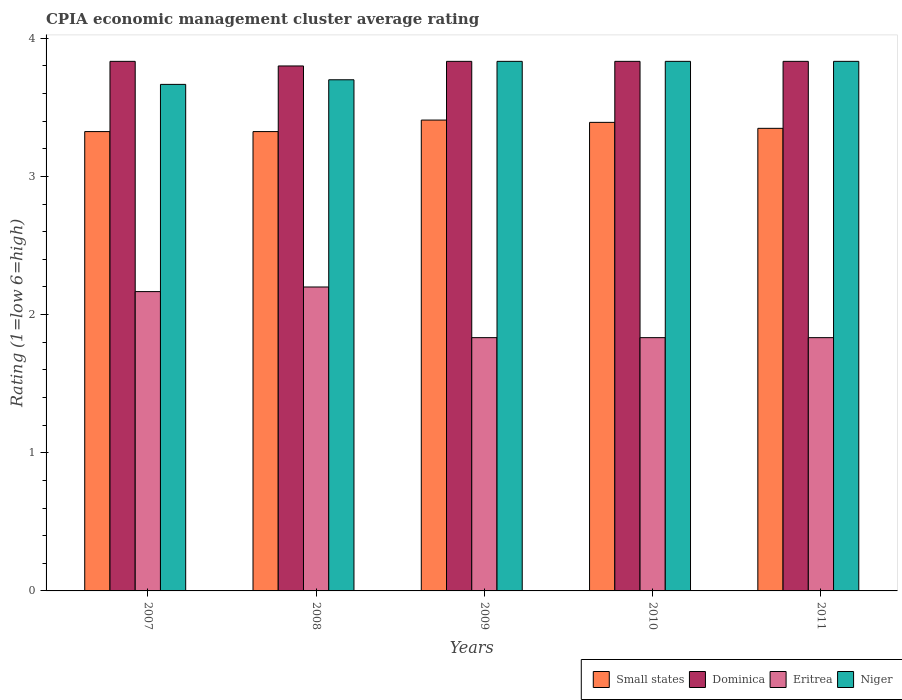How many different coloured bars are there?
Keep it short and to the point. 4. How many bars are there on the 2nd tick from the right?
Keep it short and to the point. 4. What is the CPIA rating in Dominica in 2009?
Make the answer very short. 3.83. Across all years, what is the maximum CPIA rating in Eritrea?
Your answer should be very brief. 2.2. Across all years, what is the minimum CPIA rating in Eritrea?
Your answer should be very brief. 1.83. In which year was the CPIA rating in Eritrea maximum?
Offer a very short reply. 2008. What is the total CPIA rating in Dominica in the graph?
Your answer should be very brief. 19.13. What is the difference between the CPIA rating in Small states in 2009 and that in 2010?
Your answer should be compact. 0.02. What is the difference between the CPIA rating in Eritrea in 2008 and the CPIA rating in Small states in 2010?
Ensure brevity in your answer.  -1.19. What is the average CPIA rating in Dominica per year?
Give a very brief answer. 3.83. In the year 2009, what is the difference between the CPIA rating in Eritrea and CPIA rating in Small states?
Your response must be concise. -1.58. In how many years, is the CPIA rating in Eritrea greater than 3.2?
Make the answer very short. 0. What is the ratio of the CPIA rating in Eritrea in 2009 to that in 2011?
Give a very brief answer. 1. What is the difference between the highest and the second highest CPIA rating in Small states?
Offer a very short reply. 0.02. What is the difference between the highest and the lowest CPIA rating in Eritrea?
Make the answer very short. 0.37. What does the 3rd bar from the left in 2009 represents?
Your response must be concise. Eritrea. What does the 3rd bar from the right in 2011 represents?
Provide a succinct answer. Dominica. Is it the case that in every year, the sum of the CPIA rating in Dominica and CPIA rating in Eritrea is greater than the CPIA rating in Niger?
Ensure brevity in your answer.  Yes. How many bars are there?
Your response must be concise. 20. Are the values on the major ticks of Y-axis written in scientific E-notation?
Ensure brevity in your answer.  No. Does the graph contain grids?
Offer a terse response. No. Where does the legend appear in the graph?
Keep it short and to the point. Bottom right. How many legend labels are there?
Provide a succinct answer. 4. What is the title of the graph?
Give a very brief answer. CPIA economic management cluster average rating. What is the label or title of the Y-axis?
Your response must be concise. Rating (1=low 6=high). What is the Rating (1=low 6=high) in Small states in 2007?
Give a very brief answer. 3.33. What is the Rating (1=low 6=high) of Dominica in 2007?
Offer a very short reply. 3.83. What is the Rating (1=low 6=high) of Eritrea in 2007?
Give a very brief answer. 2.17. What is the Rating (1=low 6=high) of Niger in 2007?
Your answer should be compact. 3.67. What is the Rating (1=low 6=high) in Small states in 2008?
Provide a short and direct response. 3.33. What is the Rating (1=low 6=high) in Dominica in 2008?
Give a very brief answer. 3.8. What is the Rating (1=low 6=high) in Eritrea in 2008?
Give a very brief answer. 2.2. What is the Rating (1=low 6=high) of Niger in 2008?
Ensure brevity in your answer.  3.7. What is the Rating (1=low 6=high) in Small states in 2009?
Your answer should be compact. 3.41. What is the Rating (1=low 6=high) in Dominica in 2009?
Provide a succinct answer. 3.83. What is the Rating (1=low 6=high) in Eritrea in 2009?
Provide a short and direct response. 1.83. What is the Rating (1=low 6=high) in Niger in 2009?
Provide a short and direct response. 3.83. What is the Rating (1=low 6=high) in Small states in 2010?
Provide a succinct answer. 3.39. What is the Rating (1=low 6=high) in Dominica in 2010?
Keep it short and to the point. 3.83. What is the Rating (1=low 6=high) in Eritrea in 2010?
Keep it short and to the point. 1.83. What is the Rating (1=low 6=high) in Niger in 2010?
Provide a succinct answer. 3.83. What is the Rating (1=low 6=high) in Small states in 2011?
Offer a terse response. 3.35. What is the Rating (1=low 6=high) in Dominica in 2011?
Ensure brevity in your answer.  3.83. What is the Rating (1=low 6=high) in Eritrea in 2011?
Your answer should be very brief. 1.83. What is the Rating (1=low 6=high) of Niger in 2011?
Your answer should be very brief. 3.83. Across all years, what is the maximum Rating (1=low 6=high) in Small states?
Your answer should be very brief. 3.41. Across all years, what is the maximum Rating (1=low 6=high) in Dominica?
Keep it short and to the point. 3.83. Across all years, what is the maximum Rating (1=low 6=high) of Eritrea?
Keep it short and to the point. 2.2. Across all years, what is the maximum Rating (1=low 6=high) in Niger?
Keep it short and to the point. 3.83. Across all years, what is the minimum Rating (1=low 6=high) in Small states?
Your answer should be very brief. 3.33. Across all years, what is the minimum Rating (1=low 6=high) of Dominica?
Your response must be concise. 3.8. Across all years, what is the minimum Rating (1=low 6=high) in Eritrea?
Provide a succinct answer. 1.83. Across all years, what is the minimum Rating (1=low 6=high) in Niger?
Keep it short and to the point. 3.67. What is the total Rating (1=low 6=high) in Small states in the graph?
Make the answer very short. 16.8. What is the total Rating (1=low 6=high) of Dominica in the graph?
Give a very brief answer. 19.13. What is the total Rating (1=low 6=high) of Eritrea in the graph?
Ensure brevity in your answer.  9.87. What is the total Rating (1=low 6=high) in Niger in the graph?
Ensure brevity in your answer.  18.87. What is the difference between the Rating (1=low 6=high) of Dominica in 2007 and that in 2008?
Provide a succinct answer. 0.03. What is the difference between the Rating (1=low 6=high) of Eritrea in 2007 and that in 2008?
Provide a succinct answer. -0.03. What is the difference between the Rating (1=low 6=high) of Niger in 2007 and that in 2008?
Your answer should be very brief. -0.03. What is the difference between the Rating (1=low 6=high) in Small states in 2007 and that in 2009?
Your response must be concise. -0.08. What is the difference between the Rating (1=low 6=high) in Dominica in 2007 and that in 2009?
Ensure brevity in your answer.  0. What is the difference between the Rating (1=low 6=high) of Small states in 2007 and that in 2010?
Offer a terse response. -0.07. What is the difference between the Rating (1=low 6=high) in Dominica in 2007 and that in 2010?
Your answer should be compact. 0. What is the difference between the Rating (1=low 6=high) of Small states in 2007 and that in 2011?
Ensure brevity in your answer.  -0.02. What is the difference between the Rating (1=low 6=high) of Eritrea in 2007 and that in 2011?
Your answer should be compact. 0.33. What is the difference between the Rating (1=low 6=high) of Niger in 2007 and that in 2011?
Keep it short and to the point. -0.17. What is the difference between the Rating (1=low 6=high) in Small states in 2008 and that in 2009?
Offer a very short reply. -0.08. What is the difference between the Rating (1=low 6=high) in Dominica in 2008 and that in 2009?
Provide a short and direct response. -0.03. What is the difference between the Rating (1=low 6=high) of Eritrea in 2008 and that in 2009?
Your response must be concise. 0.37. What is the difference between the Rating (1=low 6=high) in Niger in 2008 and that in 2009?
Give a very brief answer. -0.13. What is the difference between the Rating (1=low 6=high) in Small states in 2008 and that in 2010?
Offer a very short reply. -0.07. What is the difference between the Rating (1=low 6=high) in Dominica in 2008 and that in 2010?
Your answer should be compact. -0.03. What is the difference between the Rating (1=low 6=high) in Eritrea in 2008 and that in 2010?
Provide a succinct answer. 0.37. What is the difference between the Rating (1=low 6=high) of Niger in 2008 and that in 2010?
Your answer should be compact. -0.13. What is the difference between the Rating (1=low 6=high) of Small states in 2008 and that in 2011?
Your answer should be compact. -0.02. What is the difference between the Rating (1=low 6=high) of Dominica in 2008 and that in 2011?
Make the answer very short. -0.03. What is the difference between the Rating (1=low 6=high) in Eritrea in 2008 and that in 2011?
Give a very brief answer. 0.37. What is the difference between the Rating (1=low 6=high) in Niger in 2008 and that in 2011?
Your answer should be very brief. -0.13. What is the difference between the Rating (1=low 6=high) in Small states in 2009 and that in 2010?
Your answer should be compact. 0.02. What is the difference between the Rating (1=low 6=high) of Dominica in 2009 and that in 2010?
Provide a short and direct response. 0. What is the difference between the Rating (1=low 6=high) in Eritrea in 2009 and that in 2010?
Your response must be concise. 0. What is the difference between the Rating (1=low 6=high) of Niger in 2009 and that in 2010?
Your answer should be very brief. 0. What is the difference between the Rating (1=low 6=high) of Small states in 2009 and that in 2011?
Your response must be concise. 0.06. What is the difference between the Rating (1=low 6=high) in Dominica in 2009 and that in 2011?
Provide a succinct answer. 0. What is the difference between the Rating (1=low 6=high) in Eritrea in 2009 and that in 2011?
Your answer should be compact. 0. What is the difference between the Rating (1=low 6=high) of Small states in 2010 and that in 2011?
Provide a short and direct response. 0.04. What is the difference between the Rating (1=low 6=high) in Small states in 2007 and the Rating (1=low 6=high) in Dominica in 2008?
Your answer should be compact. -0.47. What is the difference between the Rating (1=low 6=high) of Small states in 2007 and the Rating (1=low 6=high) of Niger in 2008?
Provide a succinct answer. -0.38. What is the difference between the Rating (1=low 6=high) of Dominica in 2007 and the Rating (1=low 6=high) of Eritrea in 2008?
Offer a terse response. 1.63. What is the difference between the Rating (1=low 6=high) of Dominica in 2007 and the Rating (1=low 6=high) of Niger in 2008?
Your response must be concise. 0.13. What is the difference between the Rating (1=low 6=high) of Eritrea in 2007 and the Rating (1=low 6=high) of Niger in 2008?
Your answer should be very brief. -1.53. What is the difference between the Rating (1=low 6=high) of Small states in 2007 and the Rating (1=low 6=high) of Dominica in 2009?
Ensure brevity in your answer.  -0.51. What is the difference between the Rating (1=low 6=high) of Small states in 2007 and the Rating (1=low 6=high) of Eritrea in 2009?
Provide a succinct answer. 1.49. What is the difference between the Rating (1=low 6=high) of Small states in 2007 and the Rating (1=low 6=high) of Niger in 2009?
Your answer should be compact. -0.51. What is the difference between the Rating (1=low 6=high) of Dominica in 2007 and the Rating (1=low 6=high) of Niger in 2009?
Offer a terse response. 0. What is the difference between the Rating (1=low 6=high) of Eritrea in 2007 and the Rating (1=low 6=high) of Niger in 2009?
Ensure brevity in your answer.  -1.67. What is the difference between the Rating (1=low 6=high) of Small states in 2007 and the Rating (1=low 6=high) of Dominica in 2010?
Offer a terse response. -0.51. What is the difference between the Rating (1=low 6=high) of Small states in 2007 and the Rating (1=low 6=high) of Eritrea in 2010?
Provide a short and direct response. 1.49. What is the difference between the Rating (1=low 6=high) in Small states in 2007 and the Rating (1=low 6=high) in Niger in 2010?
Offer a very short reply. -0.51. What is the difference between the Rating (1=low 6=high) in Dominica in 2007 and the Rating (1=low 6=high) in Niger in 2010?
Ensure brevity in your answer.  0. What is the difference between the Rating (1=low 6=high) in Eritrea in 2007 and the Rating (1=low 6=high) in Niger in 2010?
Your response must be concise. -1.67. What is the difference between the Rating (1=low 6=high) of Small states in 2007 and the Rating (1=low 6=high) of Dominica in 2011?
Your answer should be very brief. -0.51. What is the difference between the Rating (1=low 6=high) in Small states in 2007 and the Rating (1=low 6=high) in Eritrea in 2011?
Keep it short and to the point. 1.49. What is the difference between the Rating (1=low 6=high) of Small states in 2007 and the Rating (1=low 6=high) of Niger in 2011?
Make the answer very short. -0.51. What is the difference between the Rating (1=low 6=high) of Eritrea in 2007 and the Rating (1=low 6=high) of Niger in 2011?
Offer a very short reply. -1.67. What is the difference between the Rating (1=low 6=high) of Small states in 2008 and the Rating (1=low 6=high) of Dominica in 2009?
Give a very brief answer. -0.51. What is the difference between the Rating (1=low 6=high) in Small states in 2008 and the Rating (1=low 6=high) in Eritrea in 2009?
Provide a short and direct response. 1.49. What is the difference between the Rating (1=low 6=high) of Small states in 2008 and the Rating (1=low 6=high) of Niger in 2009?
Make the answer very short. -0.51. What is the difference between the Rating (1=low 6=high) of Dominica in 2008 and the Rating (1=low 6=high) of Eritrea in 2009?
Ensure brevity in your answer.  1.97. What is the difference between the Rating (1=low 6=high) in Dominica in 2008 and the Rating (1=low 6=high) in Niger in 2009?
Your response must be concise. -0.03. What is the difference between the Rating (1=low 6=high) of Eritrea in 2008 and the Rating (1=low 6=high) of Niger in 2009?
Offer a terse response. -1.63. What is the difference between the Rating (1=low 6=high) of Small states in 2008 and the Rating (1=low 6=high) of Dominica in 2010?
Offer a very short reply. -0.51. What is the difference between the Rating (1=low 6=high) in Small states in 2008 and the Rating (1=low 6=high) in Eritrea in 2010?
Provide a succinct answer. 1.49. What is the difference between the Rating (1=low 6=high) of Small states in 2008 and the Rating (1=low 6=high) of Niger in 2010?
Your answer should be very brief. -0.51. What is the difference between the Rating (1=low 6=high) in Dominica in 2008 and the Rating (1=low 6=high) in Eritrea in 2010?
Ensure brevity in your answer.  1.97. What is the difference between the Rating (1=low 6=high) of Dominica in 2008 and the Rating (1=low 6=high) of Niger in 2010?
Your answer should be compact. -0.03. What is the difference between the Rating (1=low 6=high) of Eritrea in 2008 and the Rating (1=low 6=high) of Niger in 2010?
Your response must be concise. -1.63. What is the difference between the Rating (1=low 6=high) in Small states in 2008 and the Rating (1=low 6=high) in Dominica in 2011?
Provide a succinct answer. -0.51. What is the difference between the Rating (1=low 6=high) of Small states in 2008 and the Rating (1=low 6=high) of Eritrea in 2011?
Your response must be concise. 1.49. What is the difference between the Rating (1=low 6=high) in Small states in 2008 and the Rating (1=low 6=high) in Niger in 2011?
Provide a short and direct response. -0.51. What is the difference between the Rating (1=low 6=high) of Dominica in 2008 and the Rating (1=low 6=high) of Eritrea in 2011?
Provide a succinct answer. 1.97. What is the difference between the Rating (1=low 6=high) of Dominica in 2008 and the Rating (1=low 6=high) of Niger in 2011?
Your answer should be compact. -0.03. What is the difference between the Rating (1=low 6=high) of Eritrea in 2008 and the Rating (1=low 6=high) of Niger in 2011?
Keep it short and to the point. -1.63. What is the difference between the Rating (1=low 6=high) of Small states in 2009 and the Rating (1=low 6=high) of Dominica in 2010?
Provide a succinct answer. -0.42. What is the difference between the Rating (1=low 6=high) in Small states in 2009 and the Rating (1=low 6=high) in Eritrea in 2010?
Give a very brief answer. 1.57. What is the difference between the Rating (1=low 6=high) of Small states in 2009 and the Rating (1=low 6=high) of Niger in 2010?
Your answer should be very brief. -0.42. What is the difference between the Rating (1=low 6=high) of Dominica in 2009 and the Rating (1=low 6=high) of Eritrea in 2010?
Make the answer very short. 2. What is the difference between the Rating (1=low 6=high) in Eritrea in 2009 and the Rating (1=low 6=high) in Niger in 2010?
Keep it short and to the point. -2. What is the difference between the Rating (1=low 6=high) of Small states in 2009 and the Rating (1=low 6=high) of Dominica in 2011?
Keep it short and to the point. -0.42. What is the difference between the Rating (1=low 6=high) of Small states in 2009 and the Rating (1=low 6=high) of Eritrea in 2011?
Provide a short and direct response. 1.57. What is the difference between the Rating (1=low 6=high) of Small states in 2009 and the Rating (1=low 6=high) of Niger in 2011?
Make the answer very short. -0.42. What is the difference between the Rating (1=low 6=high) in Dominica in 2009 and the Rating (1=low 6=high) in Eritrea in 2011?
Keep it short and to the point. 2. What is the difference between the Rating (1=low 6=high) of Small states in 2010 and the Rating (1=low 6=high) of Dominica in 2011?
Offer a very short reply. -0.44. What is the difference between the Rating (1=low 6=high) in Small states in 2010 and the Rating (1=low 6=high) in Eritrea in 2011?
Provide a short and direct response. 1.56. What is the difference between the Rating (1=low 6=high) of Small states in 2010 and the Rating (1=low 6=high) of Niger in 2011?
Keep it short and to the point. -0.44. What is the difference between the Rating (1=low 6=high) in Dominica in 2010 and the Rating (1=low 6=high) in Eritrea in 2011?
Your response must be concise. 2. What is the average Rating (1=low 6=high) of Small states per year?
Ensure brevity in your answer.  3.36. What is the average Rating (1=low 6=high) in Dominica per year?
Provide a short and direct response. 3.83. What is the average Rating (1=low 6=high) in Eritrea per year?
Give a very brief answer. 1.97. What is the average Rating (1=low 6=high) of Niger per year?
Offer a very short reply. 3.77. In the year 2007, what is the difference between the Rating (1=low 6=high) of Small states and Rating (1=low 6=high) of Dominica?
Offer a terse response. -0.51. In the year 2007, what is the difference between the Rating (1=low 6=high) of Small states and Rating (1=low 6=high) of Eritrea?
Make the answer very short. 1.16. In the year 2007, what is the difference between the Rating (1=low 6=high) of Small states and Rating (1=low 6=high) of Niger?
Make the answer very short. -0.34. In the year 2007, what is the difference between the Rating (1=low 6=high) in Dominica and Rating (1=low 6=high) in Eritrea?
Offer a very short reply. 1.67. In the year 2007, what is the difference between the Rating (1=low 6=high) of Eritrea and Rating (1=low 6=high) of Niger?
Your answer should be very brief. -1.5. In the year 2008, what is the difference between the Rating (1=low 6=high) of Small states and Rating (1=low 6=high) of Dominica?
Ensure brevity in your answer.  -0.47. In the year 2008, what is the difference between the Rating (1=low 6=high) of Small states and Rating (1=low 6=high) of Niger?
Provide a short and direct response. -0.38. In the year 2008, what is the difference between the Rating (1=low 6=high) of Dominica and Rating (1=low 6=high) of Niger?
Offer a very short reply. 0.1. In the year 2009, what is the difference between the Rating (1=low 6=high) of Small states and Rating (1=low 6=high) of Dominica?
Keep it short and to the point. -0.42. In the year 2009, what is the difference between the Rating (1=low 6=high) of Small states and Rating (1=low 6=high) of Eritrea?
Keep it short and to the point. 1.57. In the year 2009, what is the difference between the Rating (1=low 6=high) of Small states and Rating (1=low 6=high) of Niger?
Your response must be concise. -0.42. In the year 2009, what is the difference between the Rating (1=low 6=high) in Dominica and Rating (1=low 6=high) in Niger?
Offer a very short reply. 0. In the year 2010, what is the difference between the Rating (1=low 6=high) of Small states and Rating (1=low 6=high) of Dominica?
Keep it short and to the point. -0.44. In the year 2010, what is the difference between the Rating (1=low 6=high) in Small states and Rating (1=low 6=high) in Eritrea?
Provide a succinct answer. 1.56. In the year 2010, what is the difference between the Rating (1=low 6=high) of Small states and Rating (1=low 6=high) of Niger?
Make the answer very short. -0.44. In the year 2011, what is the difference between the Rating (1=low 6=high) of Small states and Rating (1=low 6=high) of Dominica?
Your answer should be very brief. -0.48. In the year 2011, what is the difference between the Rating (1=low 6=high) of Small states and Rating (1=low 6=high) of Eritrea?
Provide a short and direct response. 1.52. In the year 2011, what is the difference between the Rating (1=low 6=high) of Small states and Rating (1=low 6=high) of Niger?
Provide a short and direct response. -0.48. In the year 2011, what is the difference between the Rating (1=low 6=high) in Dominica and Rating (1=low 6=high) in Eritrea?
Your answer should be compact. 2. In the year 2011, what is the difference between the Rating (1=low 6=high) of Dominica and Rating (1=low 6=high) of Niger?
Offer a very short reply. 0. What is the ratio of the Rating (1=low 6=high) of Dominica in 2007 to that in 2008?
Ensure brevity in your answer.  1.01. What is the ratio of the Rating (1=low 6=high) of Eritrea in 2007 to that in 2008?
Your answer should be compact. 0.98. What is the ratio of the Rating (1=low 6=high) of Small states in 2007 to that in 2009?
Make the answer very short. 0.98. What is the ratio of the Rating (1=low 6=high) in Eritrea in 2007 to that in 2009?
Your response must be concise. 1.18. What is the ratio of the Rating (1=low 6=high) in Niger in 2007 to that in 2009?
Your response must be concise. 0.96. What is the ratio of the Rating (1=low 6=high) in Small states in 2007 to that in 2010?
Give a very brief answer. 0.98. What is the ratio of the Rating (1=low 6=high) of Eritrea in 2007 to that in 2010?
Your answer should be compact. 1.18. What is the ratio of the Rating (1=low 6=high) in Niger in 2007 to that in 2010?
Offer a very short reply. 0.96. What is the ratio of the Rating (1=low 6=high) of Small states in 2007 to that in 2011?
Keep it short and to the point. 0.99. What is the ratio of the Rating (1=low 6=high) in Eritrea in 2007 to that in 2011?
Provide a succinct answer. 1.18. What is the ratio of the Rating (1=low 6=high) in Niger in 2007 to that in 2011?
Your response must be concise. 0.96. What is the ratio of the Rating (1=low 6=high) in Small states in 2008 to that in 2009?
Offer a terse response. 0.98. What is the ratio of the Rating (1=low 6=high) in Dominica in 2008 to that in 2009?
Ensure brevity in your answer.  0.99. What is the ratio of the Rating (1=low 6=high) of Eritrea in 2008 to that in 2009?
Your response must be concise. 1.2. What is the ratio of the Rating (1=low 6=high) of Niger in 2008 to that in 2009?
Provide a short and direct response. 0.97. What is the ratio of the Rating (1=low 6=high) of Small states in 2008 to that in 2010?
Offer a very short reply. 0.98. What is the ratio of the Rating (1=low 6=high) in Niger in 2008 to that in 2010?
Ensure brevity in your answer.  0.97. What is the ratio of the Rating (1=low 6=high) of Eritrea in 2008 to that in 2011?
Your answer should be very brief. 1.2. What is the ratio of the Rating (1=low 6=high) in Niger in 2008 to that in 2011?
Offer a terse response. 0.97. What is the ratio of the Rating (1=low 6=high) of Small states in 2009 to that in 2010?
Offer a very short reply. 1. What is the ratio of the Rating (1=low 6=high) of Dominica in 2009 to that in 2010?
Give a very brief answer. 1. What is the ratio of the Rating (1=low 6=high) of Small states in 2009 to that in 2011?
Your answer should be very brief. 1.02. What is the ratio of the Rating (1=low 6=high) in Dominica in 2009 to that in 2011?
Ensure brevity in your answer.  1. What is the ratio of the Rating (1=low 6=high) of Eritrea in 2009 to that in 2011?
Give a very brief answer. 1. What is the ratio of the Rating (1=low 6=high) in Niger in 2009 to that in 2011?
Offer a terse response. 1. What is the ratio of the Rating (1=low 6=high) of Small states in 2010 to that in 2011?
Make the answer very short. 1.01. What is the difference between the highest and the second highest Rating (1=low 6=high) of Small states?
Offer a very short reply. 0.02. What is the difference between the highest and the second highest Rating (1=low 6=high) of Niger?
Keep it short and to the point. 0. What is the difference between the highest and the lowest Rating (1=low 6=high) in Small states?
Offer a terse response. 0.08. What is the difference between the highest and the lowest Rating (1=low 6=high) in Eritrea?
Your response must be concise. 0.37. What is the difference between the highest and the lowest Rating (1=low 6=high) of Niger?
Ensure brevity in your answer.  0.17. 